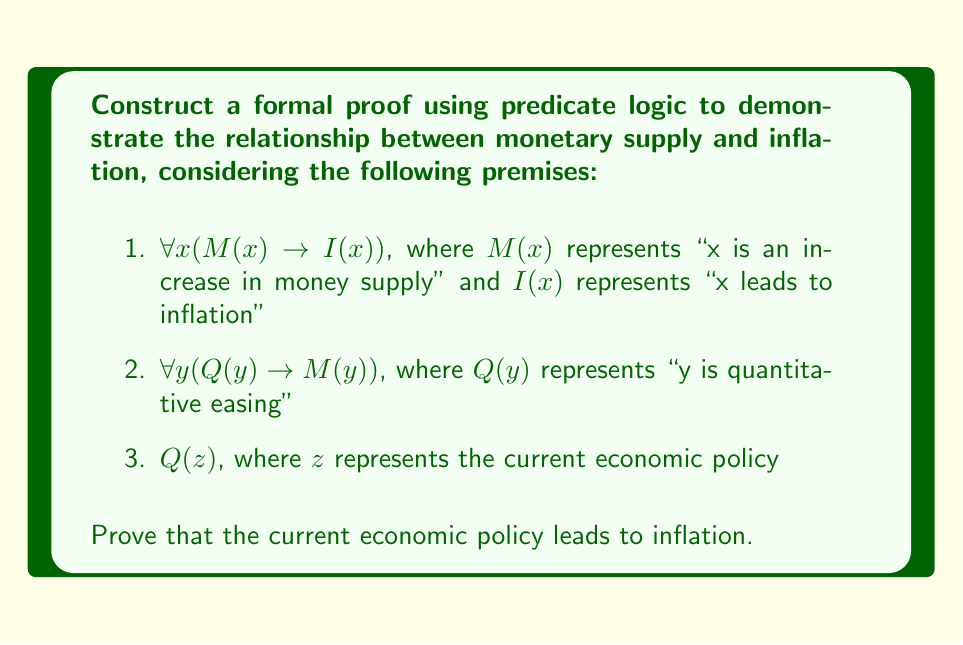Provide a solution to this math problem. To construct a formal proof for this problem, we will use predicate logic and the rules of inference. Let's proceed step by step:

1. We start with our given premises:
   a. $\forall x (M(x) \rightarrow I(x))$
   b. $\forall y (Q(y) \rightarrow M(y))$
   c. $Q(z)$

2. Our goal is to prove $I(z)$, which would show that the current economic policy leads to inflation.

3. From premise (c), we know that $Q(z)$ is true.

4. We can apply Universal Instantiation to premise (b), replacing $y$ with $z$:
   $Q(z) \rightarrow M(z)$

5. Now we can use Modus Ponens with the result from step 4 and premise (c):
   $Q(z)$ (given)
   $Q(z) \rightarrow M(z)$ (from step 4)
   Therefore, $M(z)$

6. We can apply Universal Instantiation to premise (a), replacing $x$ with $z$:
   $M(z) \rightarrow I(z)$

7. Finally, we can use Modus Ponens again with the result from step 5 and step 6:
   $M(z)$ (from step 5)
   $M(z) \rightarrow I(z)$ (from step 6)
   Therefore, $I(z)$

This completes our proof, showing that the current economic policy ($z$) leads to inflation.
Answer: The formal proof demonstrates that $I(z)$ is true, which means the current economic policy leads to inflation. This conclusion is derived through the application of Universal Instantiation and Modus Ponens to the given premises, establishing a logical connection between quantitative easing, increase in money supply, and inflation. 